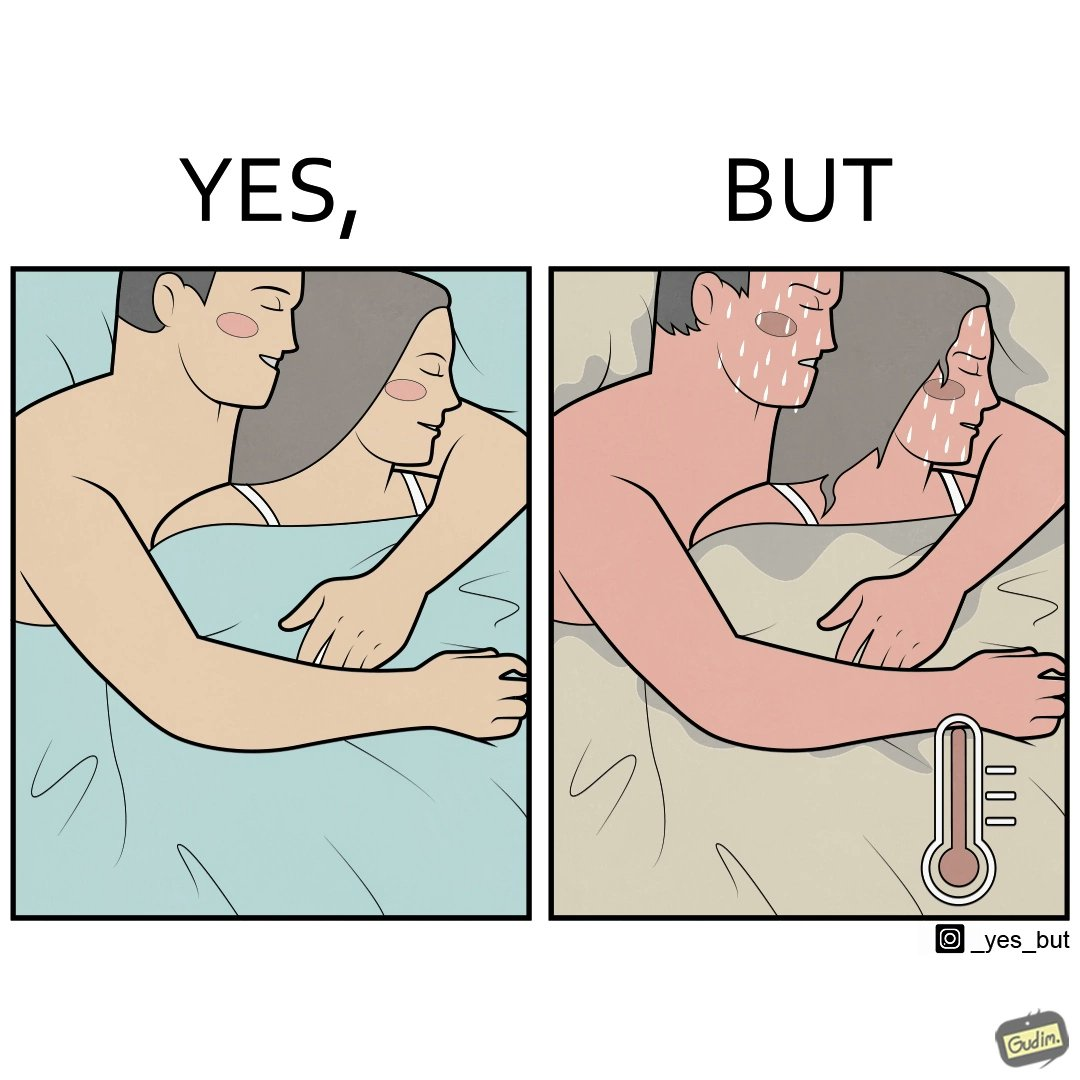Explain why this image is satirical. The image is ironic, because after some time cuddling within a blanket raises the temperature which leads to inconvenience 